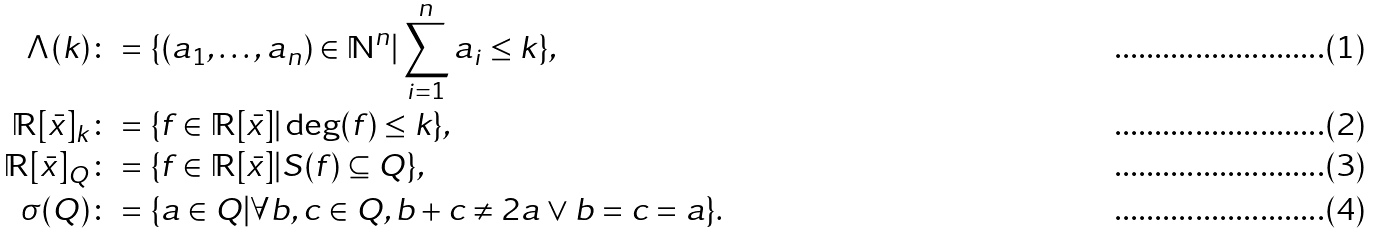<formula> <loc_0><loc_0><loc_500><loc_500>\Lambda ( k ) \colon & = \{ ( a _ { 1 } , \dots , a _ { n } ) \in \mathbb { N } ^ { n } | \sum _ { i = 1 } ^ { n } a _ { i } \leq k \} , \\ \mathbb { R } [ \bar { x } ] _ { k } \colon & = \{ f \in \mathbb { R } [ \bar { x } ] | \deg ( f ) \leq k \} , \\ \mathbb { R } [ \bar { x } ] _ { Q } \colon & = \{ f \in \mathbb { R } [ \bar { x } ] | S ( f ) \subseteq Q \} , \\ \sigma ( Q ) \colon & = \{ a \in Q | \forall b , c \in Q , b + c \neq 2 a \lor b = c = a \} .</formula> 